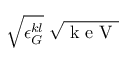Convert formula to latex. <formula><loc_0><loc_0><loc_500><loc_500>\sqrt { \epsilon _ { G } ^ { k l } } \, \sqrt { k e V }</formula> 